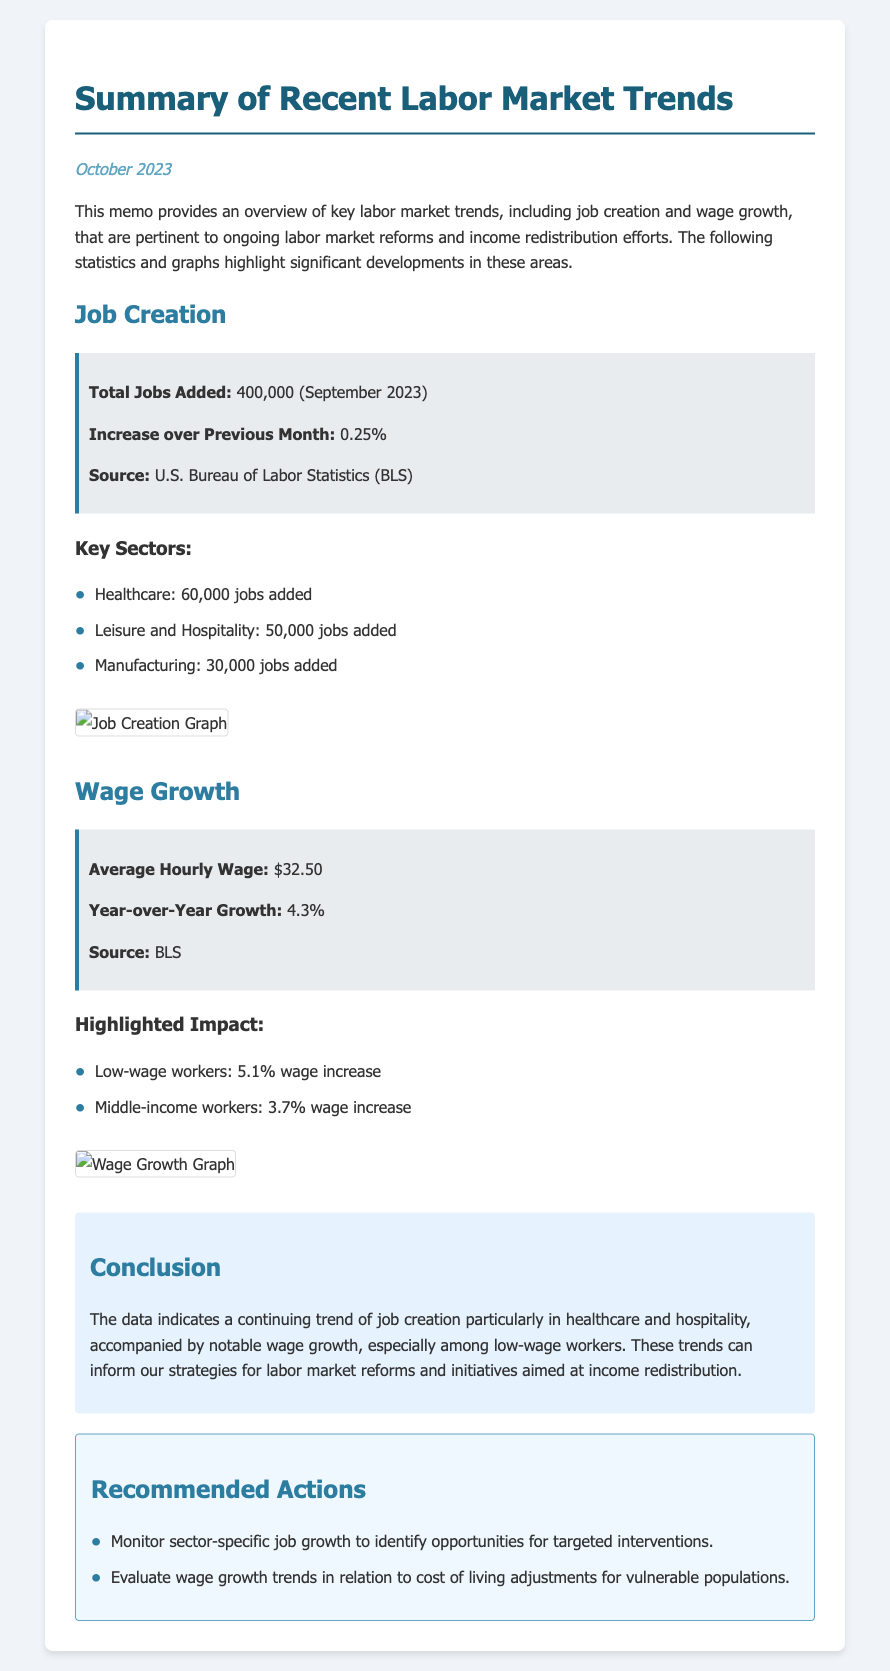What is the total jobs added in September 2023? The total jobs added is indicated in the document as 400,000 for September 2023.
Answer: 400,000 What is the year-over-year wage growth? The document specifies the year-over-year wage growth as 4.3%.
Answer: 4.3% Which sector added the most jobs in September 2023? The document lists healthcare as the sector that added the most jobs, at 60,000.
Answer: Healthcare What was the increase in jobs over the previous month? The document states the increase over the previous month was 0.25%.
Answer: 0.25% What is the average hourly wage according to the memo? The average hourly wage mentioned in the document is $32.50.
Answer: $32.50 What type of workers saw a 5.1% wage increase? The document highlights low-wage workers as those who experienced a 5.1% wage increase.
Answer: Low-wage workers What is one recommended action mentioned in the memo? The document suggests monitoring sector-specific job growth as a recommended action.
Answer: Monitor sector-specific job growth What is the source of the job creation data? The document identifies the source of the job creation data as the U.S. Bureau of Labor Statistics (BLS).
Answer: U.S. Bureau of Labor Statistics (BLS) What does the conclusion indicate about job creation trends? The conclusion notes that there is a continuing trend of job creation particularly in healthcare and hospitality.
Answer: Continuing trend of job creation in healthcare and hospitality 